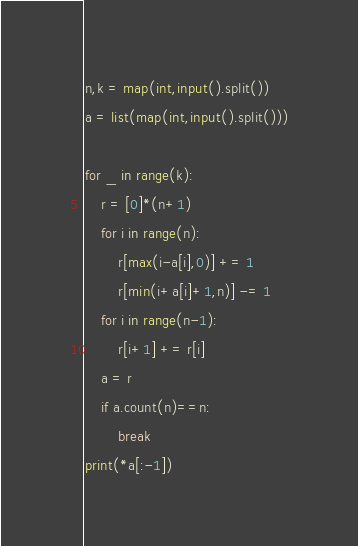Convert code to text. <code><loc_0><loc_0><loc_500><loc_500><_Python_>n,k = map(int,input().split())
a = list(map(int,input().split()))

for _ in range(k):
    r = [0]*(n+1)
    for i in range(n):
        r[max(i-a[i],0)] += 1
        r[min(i+a[i]+1,n)] -= 1
    for i in range(n-1):
        r[i+1] += r[i]
    a = r
    if a.count(n)==n:
        break
print(*a[:-1])
</code> 